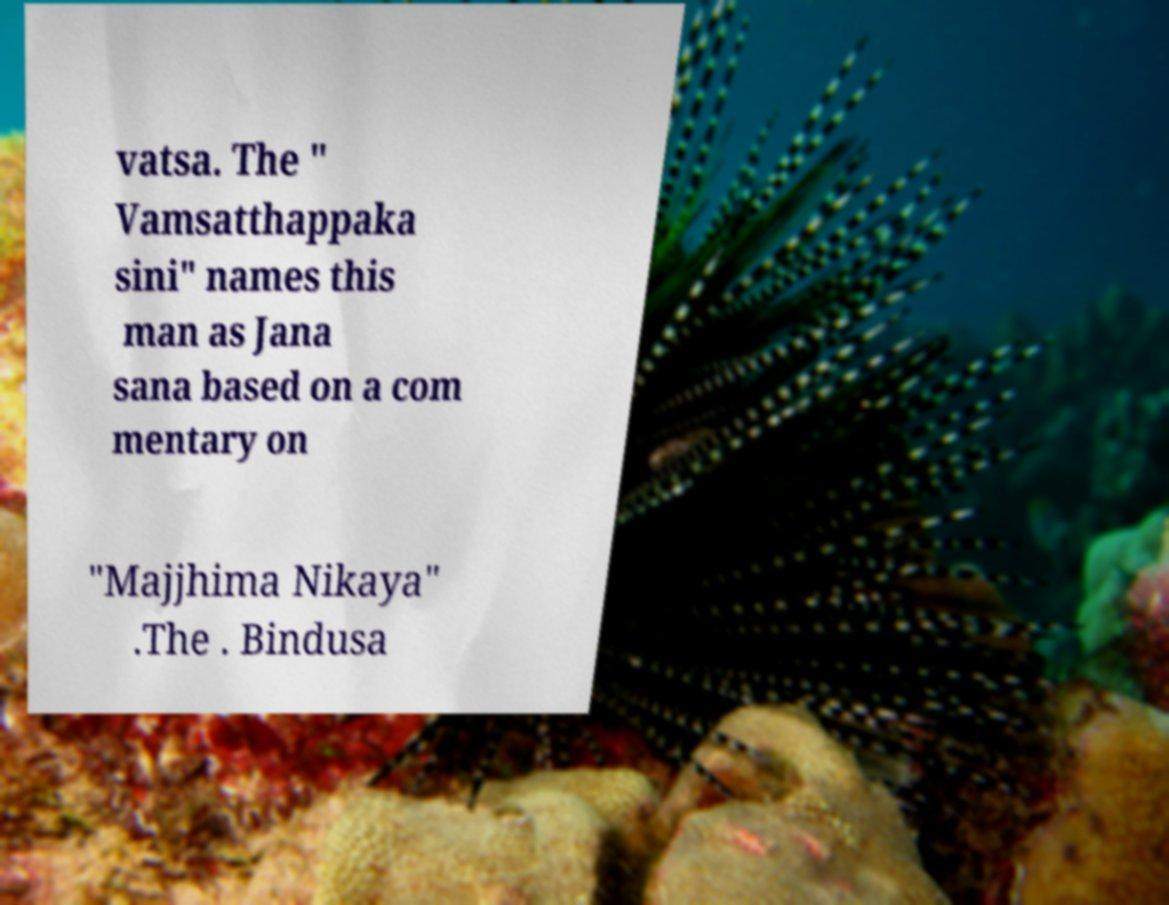Could you assist in decoding the text presented in this image and type it out clearly? vatsa. The " Vamsatthappaka sini" names this man as Jana sana based on a com mentary on "Majjhima Nikaya" .The . Bindusa 